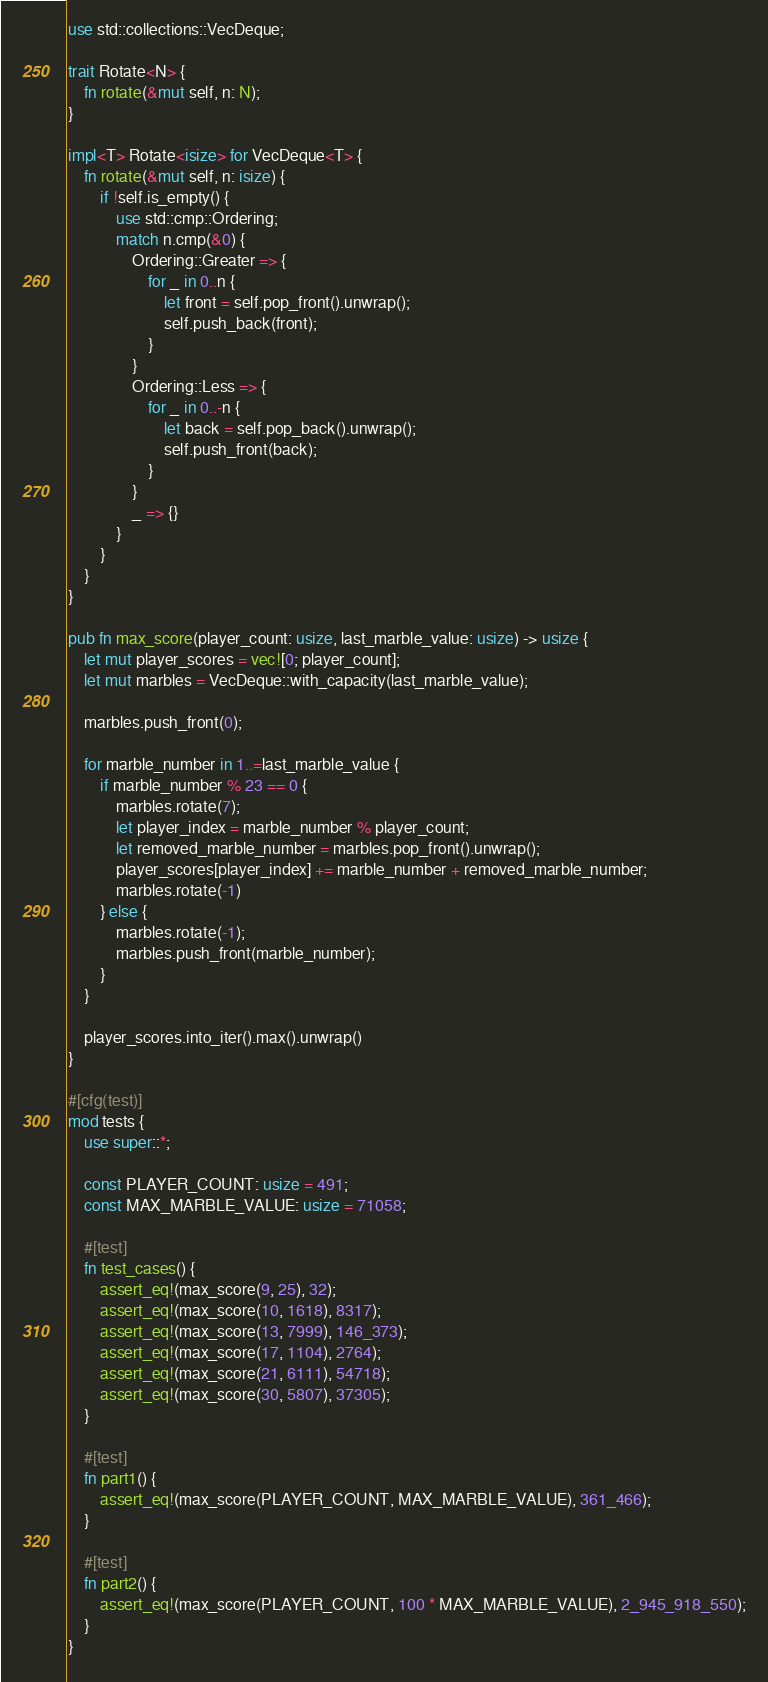Convert code to text. <code><loc_0><loc_0><loc_500><loc_500><_Rust_>use std::collections::VecDeque;

trait Rotate<N> {
    fn rotate(&mut self, n: N);
}

impl<T> Rotate<isize> for VecDeque<T> {
    fn rotate(&mut self, n: isize) {
        if !self.is_empty() {
            use std::cmp::Ordering;
            match n.cmp(&0) {
                Ordering::Greater => {
                    for _ in 0..n {
                        let front = self.pop_front().unwrap();
                        self.push_back(front);
                    }
                }
                Ordering::Less => {
                    for _ in 0..-n {
                        let back = self.pop_back().unwrap();
                        self.push_front(back);
                    }
                }
                _ => {}
            }
        }
    }
}

pub fn max_score(player_count: usize, last_marble_value: usize) -> usize {
    let mut player_scores = vec![0; player_count];
    let mut marbles = VecDeque::with_capacity(last_marble_value);

    marbles.push_front(0);

    for marble_number in 1..=last_marble_value {
        if marble_number % 23 == 0 {
            marbles.rotate(7);
            let player_index = marble_number % player_count;
            let removed_marble_number = marbles.pop_front().unwrap();
            player_scores[player_index] += marble_number + removed_marble_number;
            marbles.rotate(-1)
        } else {
            marbles.rotate(-1);
            marbles.push_front(marble_number);
        }
    }

    player_scores.into_iter().max().unwrap()
}

#[cfg(test)]
mod tests {
    use super::*;

    const PLAYER_COUNT: usize = 491;
    const MAX_MARBLE_VALUE: usize = 71058;

    #[test]
    fn test_cases() {
        assert_eq!(max_score(9, 25), 32);
        assert_eq!(max_score(10, 1618), 8317);
        assert_eq!(max_score(13, 7999), 146_373);
        assert_eq!(max_score(17, 1104), 2764);
        assert_eq!(max_score(21, 6111), 54718);
        assert_eq!(max_score(30, 5807), 37305);
    }

    #[test]
    fn part1() {
        assert_eq!(max_score(PLAYER_COUNT, MAX_MARBLE_VALUE), 361_466);
    }

    #[test]
    fn part2() {
        assert_eq!(max_score(PLAYER_COUNT, 100 * MAX_MARBLE_VALUE), 2_945_918_550);
    }
}
</code> 